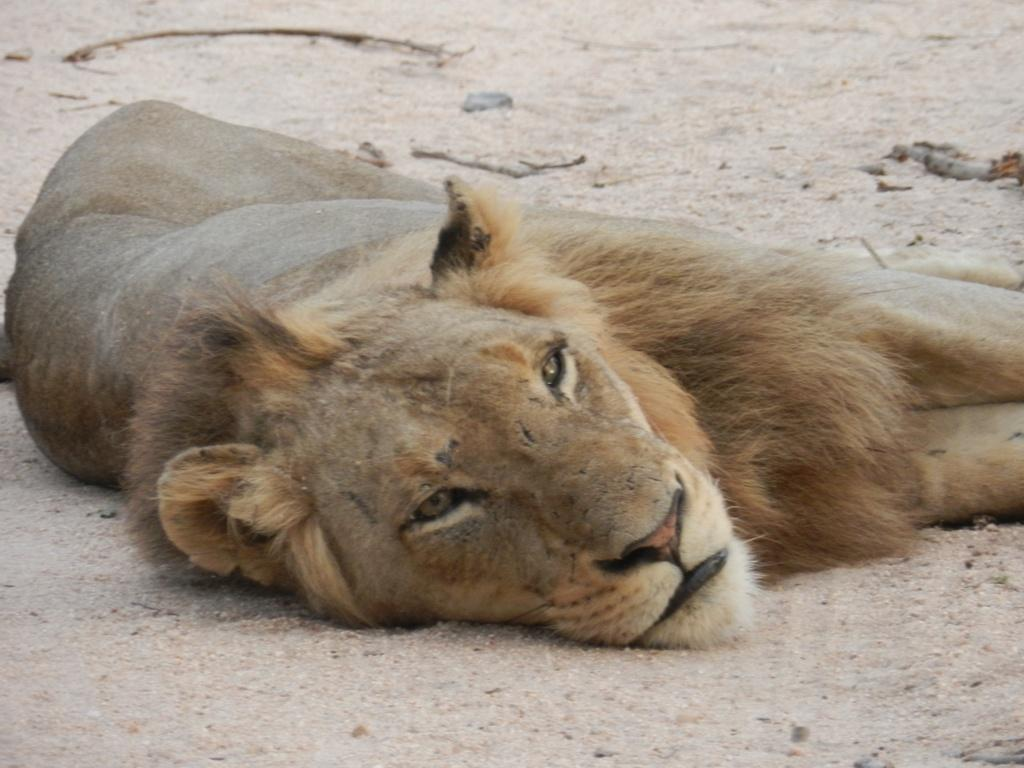What animal is present in the image? There is a lion in the image. What is the lion doing in the image? The lion is lying on the ground. When was the image taken? The image was taken during the day. What type of carriage can be seen being pulled by the lion in the image? There is no carriage present in the image; it only features a lion lying on the ground. What is the shape of the neck of the lion in the image? The image does not provide enough detail to determine the shape of the lion's neck. 